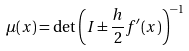Convert formula to latex. <formula><loc_0><loc_0><loc_500><loc_500>\mu ( x ) = \det \left ( I \pm \frac { h } { 2 } f ^ { \prime } ( x ) \right ) ^ { - 1 }</formula> 